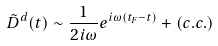Convert formula to latex. <formula><loc_0><loc_0><loc_500><loc_500>\tilde { D } ^ { d } ( t ) \sim \frac { 1 } { 2 i \omega } e ^ { i \omega ( t _ { F } - t ) } + ( c . c . )</formula> 